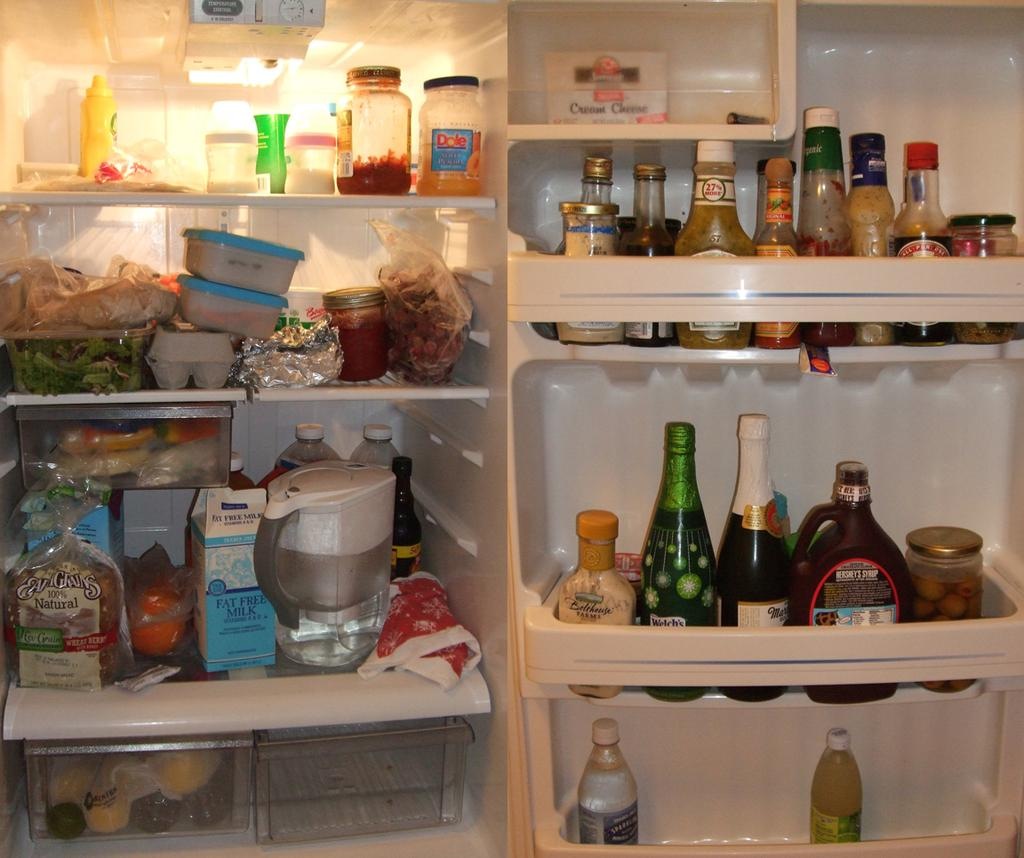<image>
Provide a brief description of the given image. a fridge that's open that has a fat free milk container on it 